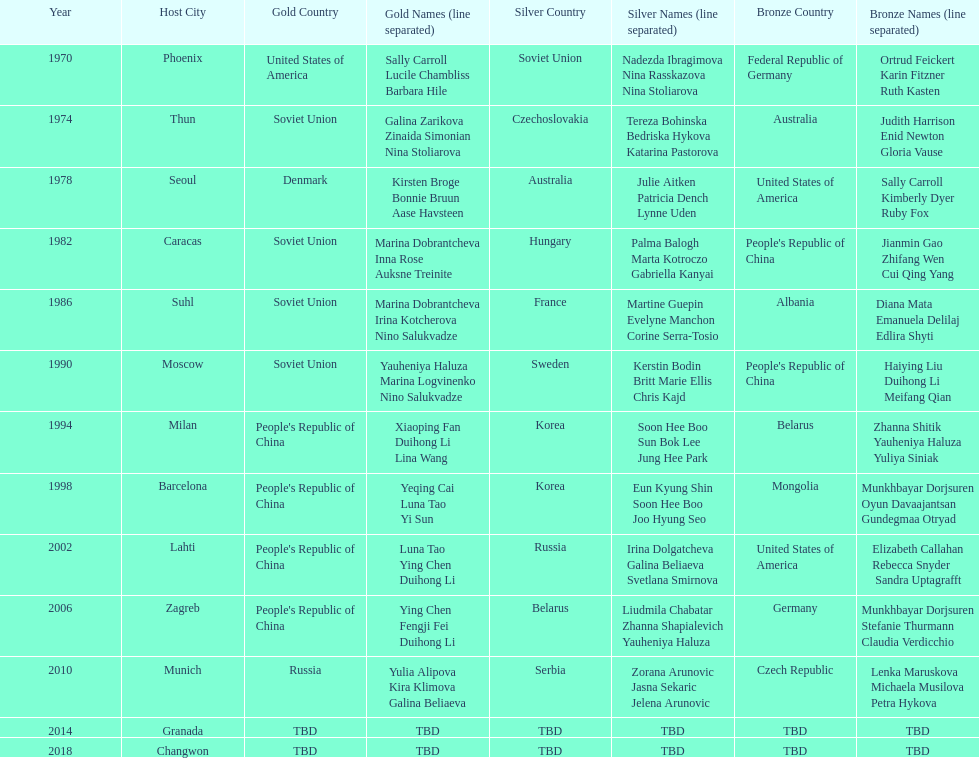Whose name is listed before bonnie bruun's in the gold column? Kirsten Broge. 